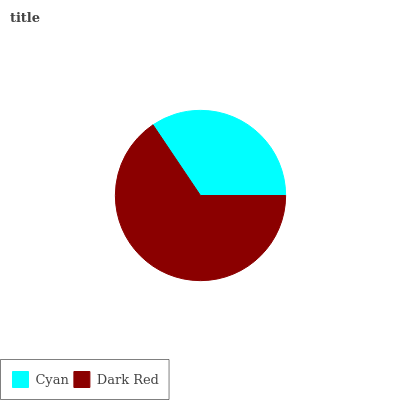Is Cyan the minimum?
Answer yes or no. Yes. Is Dark Red the maximum?
Answer yes or no. Yes. Is Dark Red the minimum?
Answer yes or no. No. Is Dark Red greater than Cyan?
Answer yes or no. Yes. Is Cyan less than Dark Red?
Answer yes or no. Yes. Is Cyan greater than Dark Red?
Answer yes or no. No. Is Dark Red less than Cyan?
Answer yes or no. No. Is Dark Red the high median?
Answer yes or no. Yes. Is Cyan the low median?
Answer yes or no. Yes. Is Cyan the high median?
Answer yes or no. No. Is Dark Red the low median?
Answer yes or no. No. 